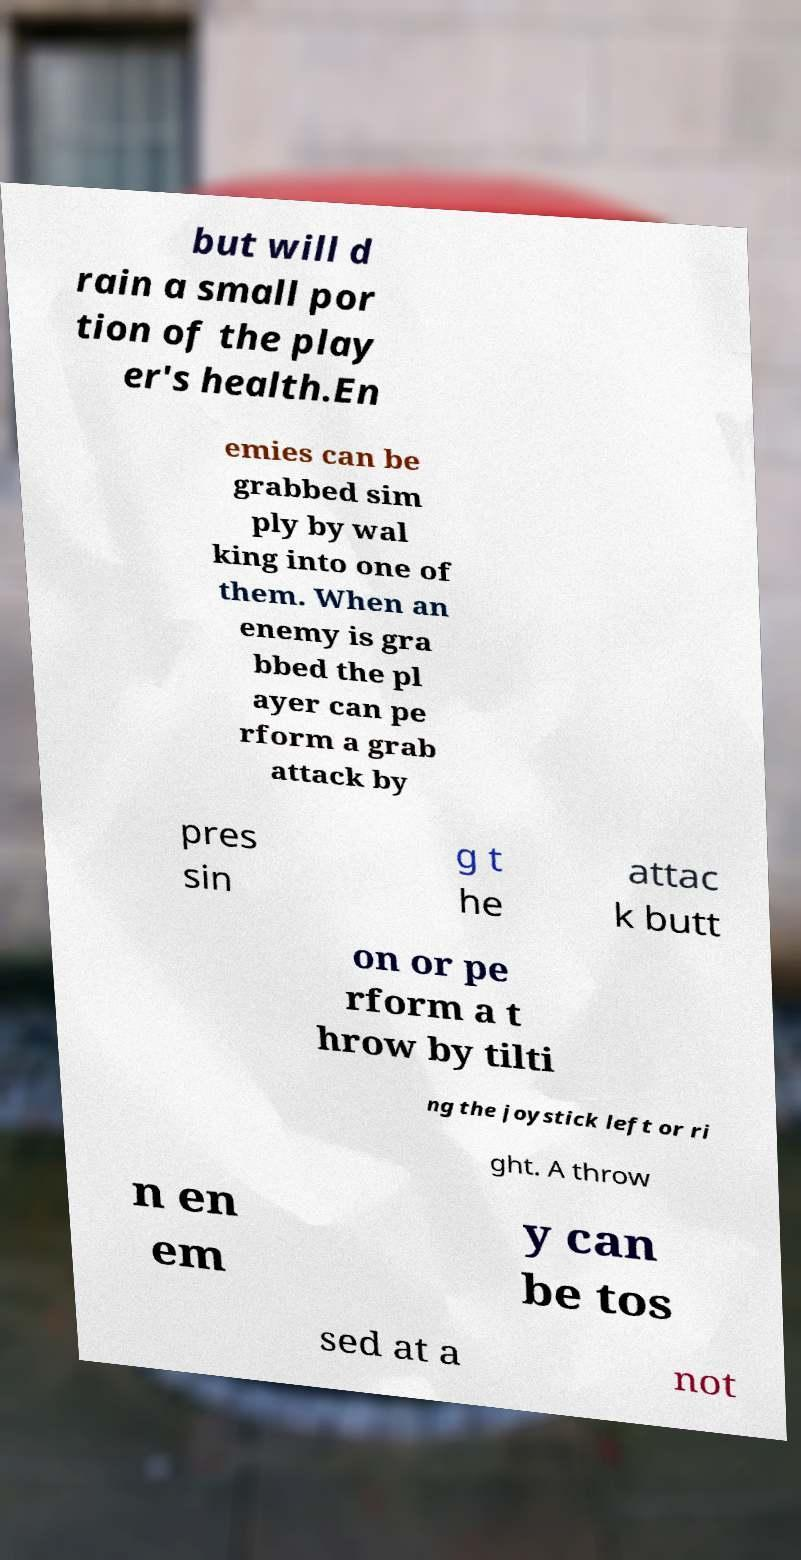For documentation purposes, I need the text within this image transcribed. Could you provide that? but will d rain a small por tion of the play er's health.En emies can be grabbed sim ply by wal king into one of them. When an enemy is gra bbed the pl ayer can pe rform a grab attack by pres sin g t he attac k butt on or pe rform a t hrow by tilti ng the joystick left or ri ght. A throw n en em y can be tos sed at a not 